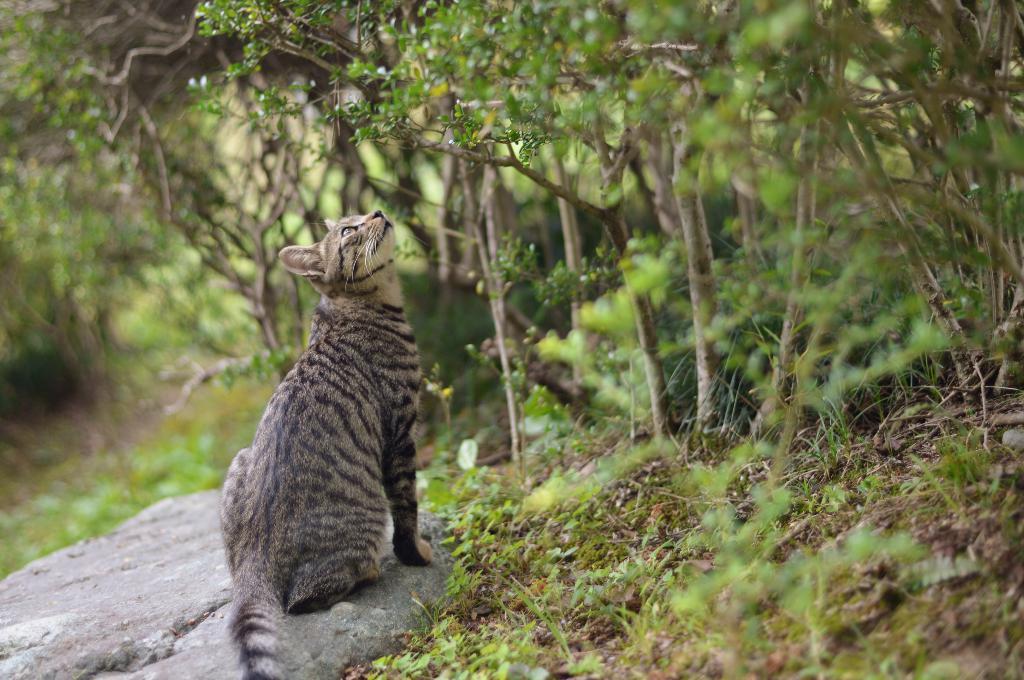Could you give a brief overview of what you see in this image? In this picture there is a cat who is sitting on the stone. In the back I can see plants, trees and grass. 